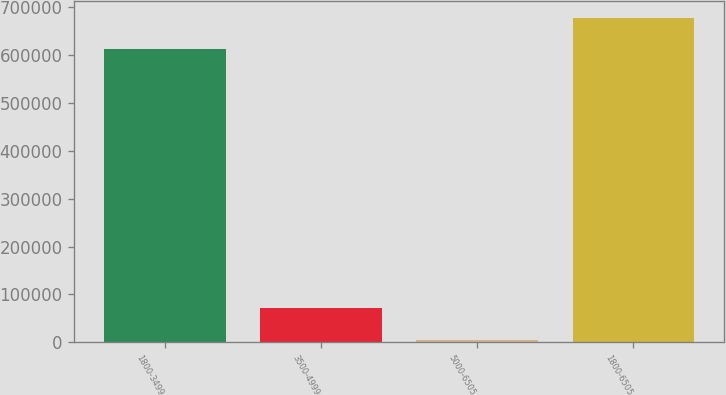Convert chart. <chart><loc_0><loc_0><loc_500><loc_500><bar_chart><fcel>1800-3499<fcel>3500-4999<fcel>5000-6505<fcel>1800-6505<nl><fcel>612783<fcel>71212.3<fcel>5833<fcel>678162<nl></chart> 